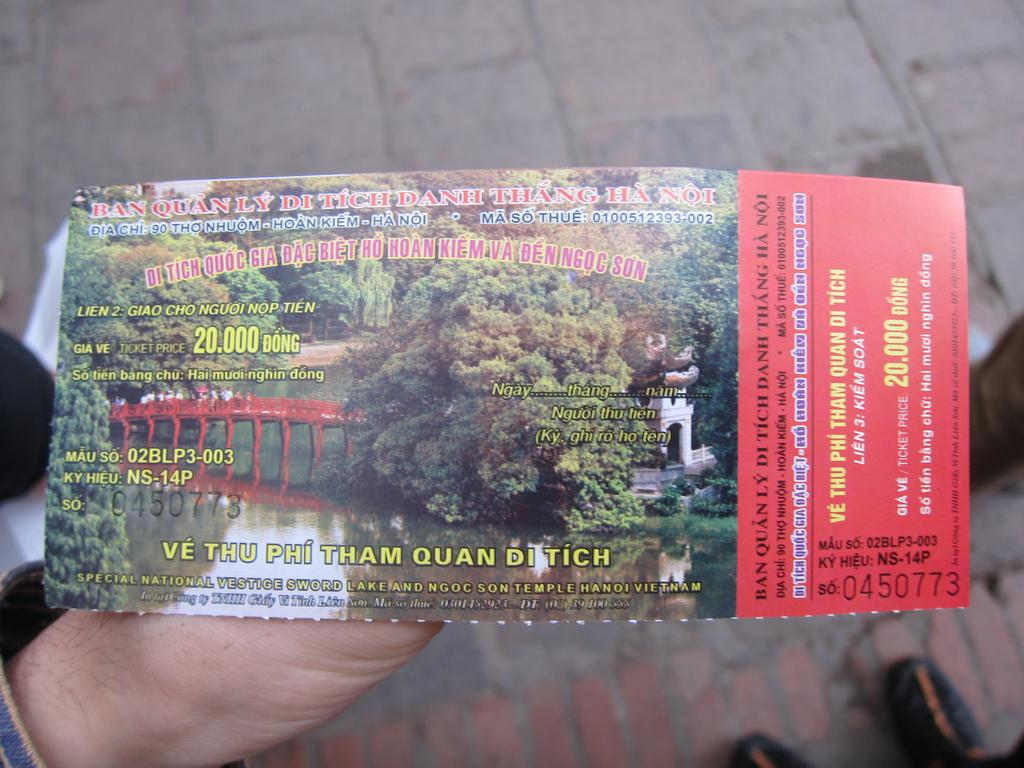<image>
Share a concise interpretation of the image provided. The ticket in the picture cost about 20,000 dong 